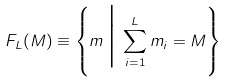Convert formula to latex. <formula><loc_0><loc_0><loc_500><loc_500>F _ { L } ( M ) \equiv \left \{ m \, \Big | \, \sum _ { i = 1 } ^ { L } m _ { i } = M \right \}</formula> 